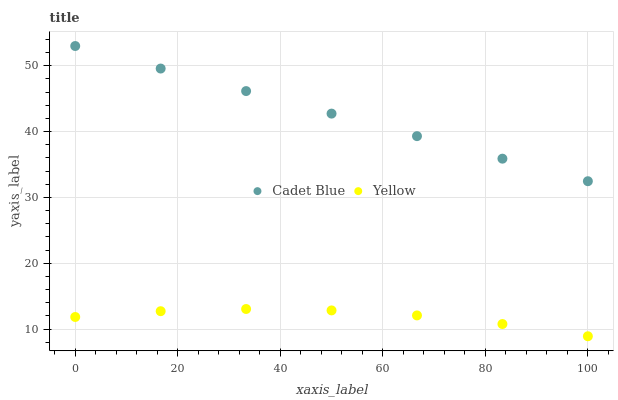Does Yellow have the minimum area under the curve?
Answer yes or no. Yes. Does Cadet Blue have the maximum area under the curve?
Answer yes or no. Yes. Does Yellow have the maximum area under the curve?
Answer yes or no. No. Is Cadet Blue the smoothest?
Answer yes or no. Yes. Is Yellow the roughest?
Answer yes or no. Yes. Is Yellow the smoothest?
Answer yes or no. No. Does Yellow have the lowest value?
Answer yes or no. Yes. Does Cadet Blue have the highest value?
Answer yes or no. Yes. Does Yellow have the highest value?
Answer yes or no. No. Is Yellow less than Cadet Blue?
Answer yes or no. Yes. Is Cadet Blue greater than Yellow?
Answer yes or no. Yes. Does Yellow intersect Cadet Blue?
Answer yes or no. No. 